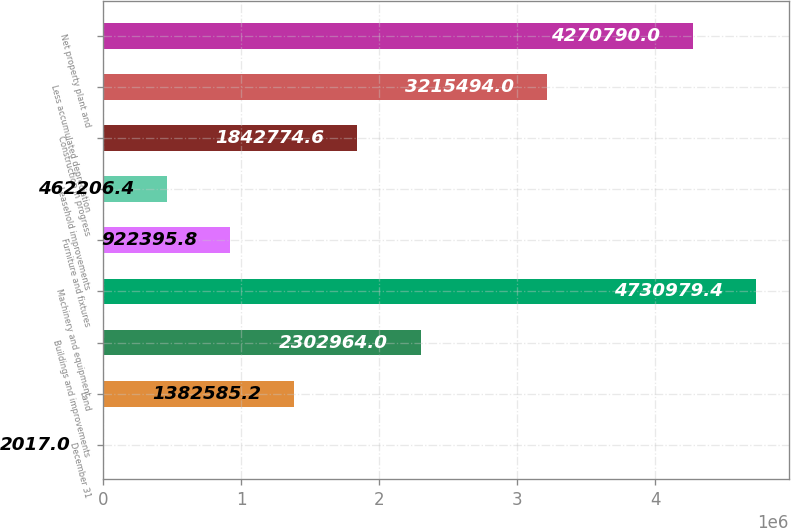Convert chart. <chart><loc_0><loc_0><loc_500><loc_500><bar_chart><fcel>December 31<fcel>Land<fcel>Buildings and improvements<fcel>Machinery and equipment<fcel>Furniture and fixtures<fcel>Leasehold improvements<fcel>Construction in progress<fcel>Less accumulated depreciation<fcel>Net property plant and<nl><fcel>2017<fcel>1.38259e+06<fcel>2.30296e+06<fcel>4.73098e+06<fcel>922396<fcel>462206<fcel>1.84277e+06<fcel>3.21549e+06<fcel>4.27079e+06<nl></chart> 